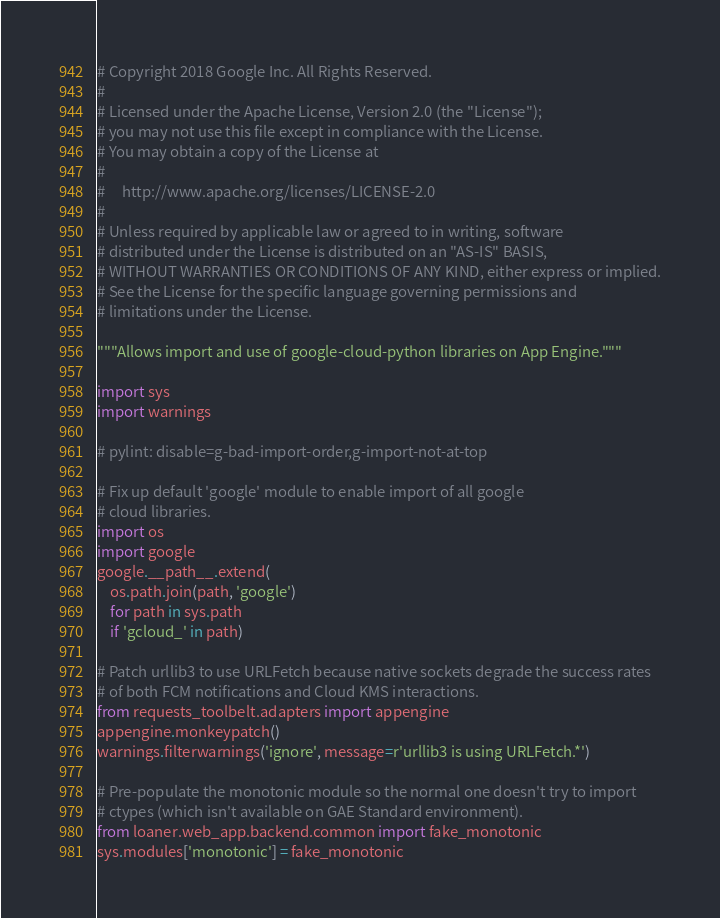Convert code to text. <code><loc_0><loc_0><loc_500><loc_500><_Python_># Copyright 2018 Google Inc. All Rights Reserved.
#
# Licensed under the Apache License, Version 2.0 (the "License");
# you may not use this file except in compliance with the License.
# You may obtain a copy of the License at
#
#     http://www.apache.org/licenses/LICENSE-2.0
#
# Unless required by applicable law or agreed to in writing, software
# distributed under the License is distributed on an "AS-IS" BASIS,
# WITHOUT WARRANTIES OR CONDITIONS OF ANY KIND, either express or implied.
# See the License for the specific language governing permissions and
# limitations under the License.

"""Allows import and use of google-cloud-python libraries on App Engine."""

import sys
import warnings

# pylint: disable=g-bad-import-order,g-import-not-at-top

# Fix up default 'google' module to enable import of all google
# cloud libraries.
import os
import google
google.__path__.extend(
    os.path.join(path, 'google')
    for path in sys.path
    if 'gcloud_' in path)

# Patch urllib3 to use URLFetch because native sockets degrade the success rates
# of both FCM notifications and Cloud KMS interactions.
from requests_toolbelt.adapters import appengine
appengine.monkeypatch()
warnings.filterwarnings('ignore', message=r'urllib3 is using URLFetch.*')

# Pre-populate the monotonic module so the normal one doesn't try to import
# ctypes (which isn't available on GAE Standard environment).
from loaner.web_app.backend.common import fake_monotonic
sys.modules['monotonic'] = fake_monotonic
</code> 